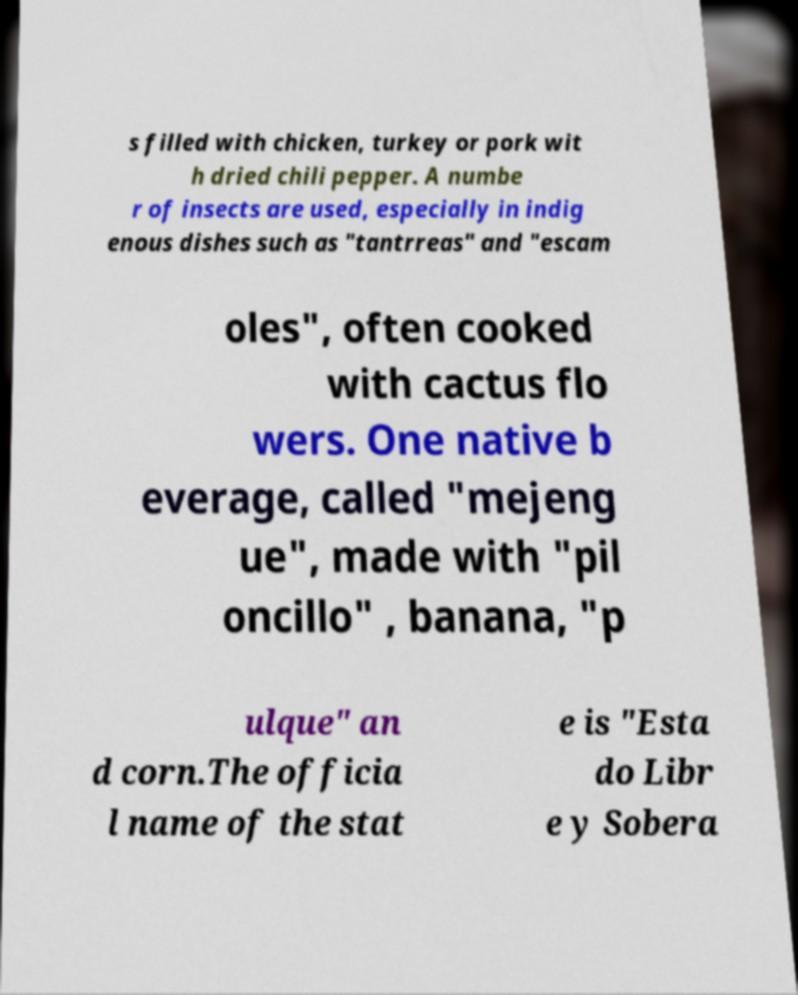Please identify and transcribe the text found in this image. s filled with chicken, turkey or pork wit h dried chili pepper. A numbe r of insects are used, especially in indig enous dishes such as "tantrreas" and "escam oles", often cooked with cactus flo wers. One native b everage, called "mejeng ue", made with "pil oncillo" , banana, "p ulque" an d corn.The officia l name of the stat e is "Esta do Libr e y Sobera 